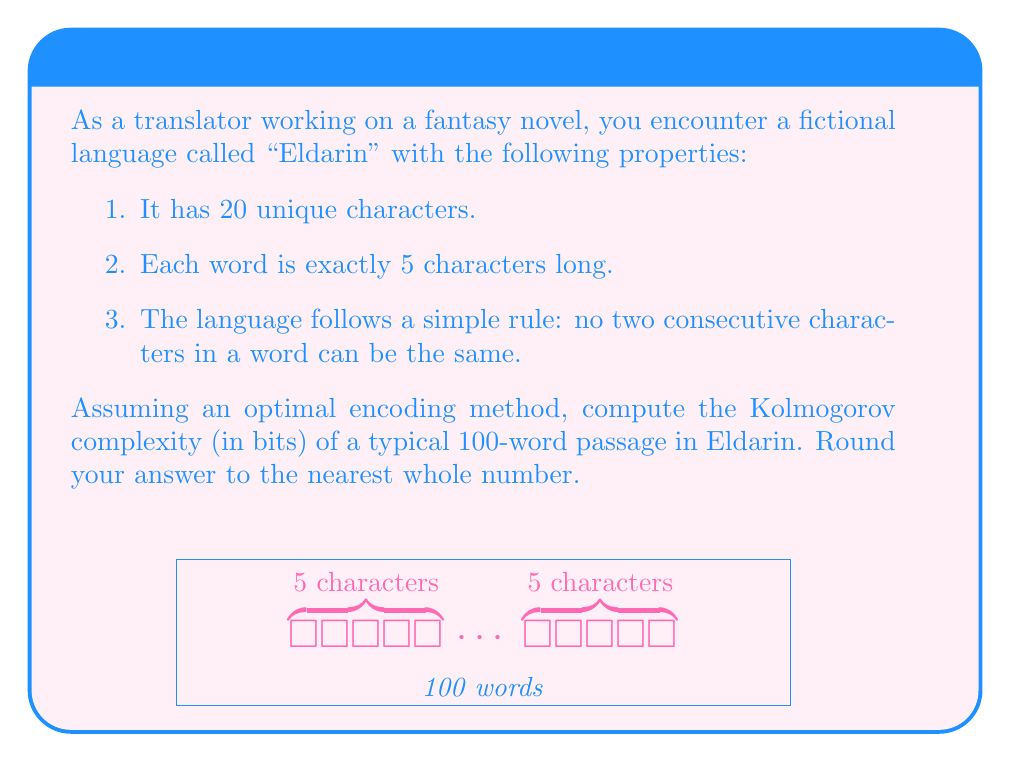Can you answer this question? Let's approach this step-by-step:

1) First, we need to calculate the number of possible words in Eldarin:
   - For the first character, we have 20 choices.
   - For each subsequent character, we have 19 choices (all except the previous character).
   
   So, the total number of possible words is:
   $$20 \times 19 \times 19 \times 19 \times 19 = 20 \times 19^4 = 2,470,000$$

2) To encode each word optimally, we need to calculate how many bits are required:
   $$\log_2(2,470,000) \approx 21.2385$$
   
   Rounding up to the nearest whole number of bits: 22 bits per word.

3) For a 100-word passage, we multiply this by 100:
   $$100 \times 22 = 2,200 \text{ bits}$$

4) The Kolmogorov complexity is the length of the shortest possible description of the data. In this case, our encoding method is already optimal given the constraints of the language, so the Kolmogorov complexity is equal to the number of bits required to encode the passage.

Therefore, the Kolmogorov complexity of a typical 100-word passage in Eldarin is 2,200 bits.
Answer: 2,200 bits 